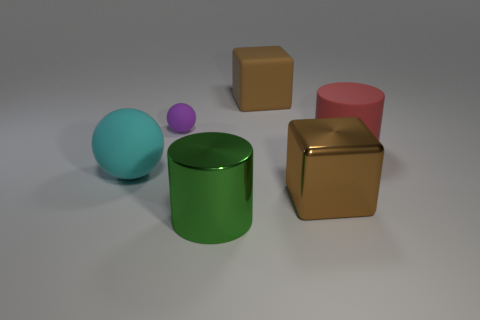Is there any other thing that is the same size as the cyan object?
Give a very brief answer. Yes. There is a cyan ball that is left of the tiny object that is behind the rubber cylinder; what is its material?
Offer a very short reply. Rubber. Are there an equal number of large spheres behind the small purple rubber object and large objects that are on the left side of the red thing?
Provide a short and direct response. No. How many objects are spheres that are to the left of the small rubber object or big things that are in front of the tiny object?
Give a very brief answer. 4. The thing that is both behind the big red object and on the right side of the large green metal thing is made of what material?
Your response must be concise. Rubber. There is a brown cube that is to the left of the block that is in front of the purple matte thing behind the large red thing; what size is it?
Make the answer very short. Large. Are there more big metal cylinders than red spheres?
Your answer should be very brief. Yes. Is the material of the big block that is to the right of the large brown rubber thing the same as the small purple ball?
Provide a succinct answer. No. Is the number of big shiny cubes less than the number of tiny blue metallic spheres?
Make the answer very short. No. Are there any large cylinders that are in front of the large thing on the left side of the big cylinder in front of the red matte cylinder?
Keep it short and to the point. Yes. 